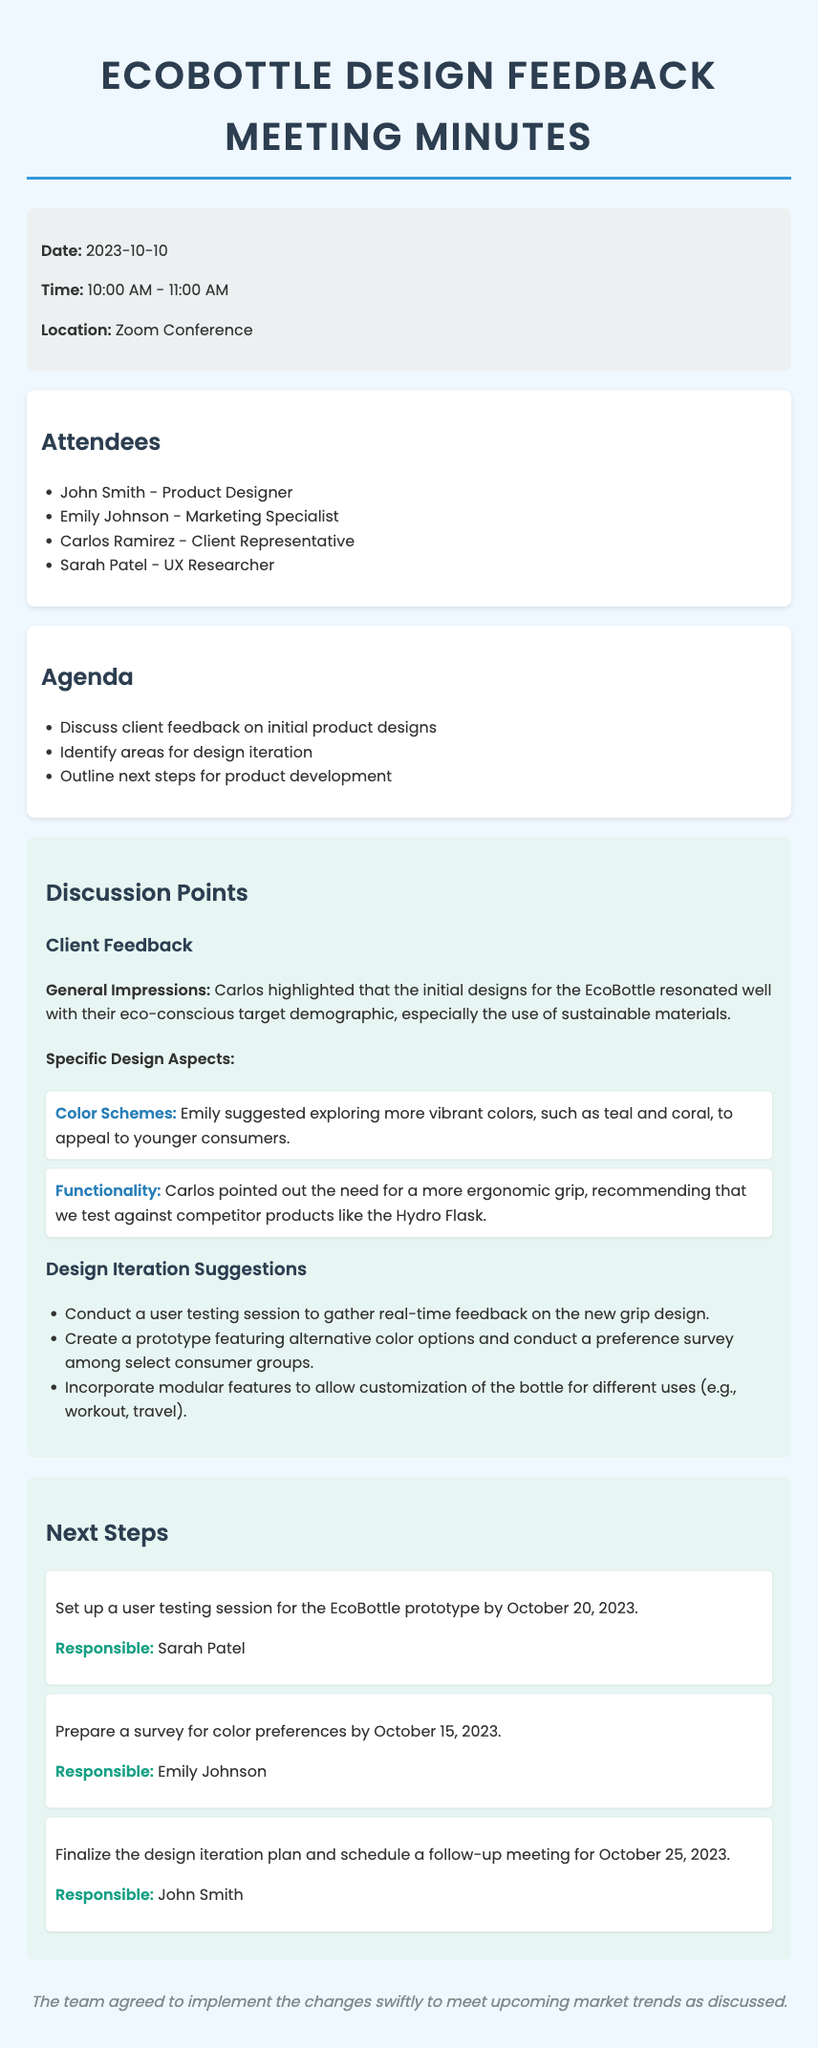what is the date of the meeting? The date is mentioned in the meeting info section of the document as October 10, 2023.
Answer: October 10, 2023 who suggested exploring more vibrant colors for the EcoBottle? The document states that Emily suggested exploring more vibrant colors to appeal to younger consumers.
Answer: Emily what functionality improvement was recommended for the EcoBottle? Carlos pointed out the need for a more ergonomic grip, referencing competitor products.
Answer: Ergonomic grip when is the deadline for preparing the color preference survey? The deadline for the survey is stated as October 15, 2023.
Answer: October 15, 2023 what is one of the design iteration suggestions mentioned? One of the suggestions involves conducting a user testing session to gather feedback on the new grip design.
Answer: Conduct user testing who is responsible for setting up the user testing session? The responsible person for the user testing session is mentioned as Sarah Patel in the next steps section.
Answer: Sarah Patel what color was specifically suggested as an alternative? The suggested vibrant colors mentioned include teal and coral in the discussion points.
Answer: Teal and coral how long was the feedback session scheduled for? The duration of the meeting is noted as one hour in the meeting info section.
Answer: One hour 